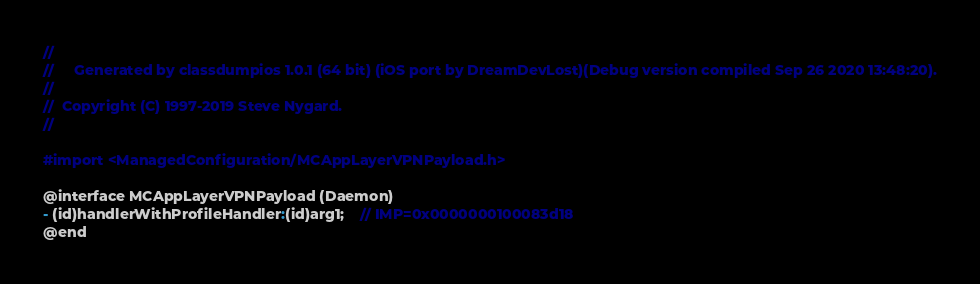Convert code to text. <code><loc_0><loc_0><loc_500><loc_500><_C_>//
//     Generated by classdumpios 1.0.1 (64 bit) (iOS port by DreamDevLost)(Debug version compiled Sep 26 2020 13:48:20).
//
//  Copyright (C) 1997-2019 Steve Nygard.
//

#import <ManagedConfiguration/MCAppLayerVPNPayload.h>

@interface MCAppLayerVPNPayload (Daemon)
- (id)handlerWithProfileHandler:(id)arg1;	// IMP=0x0000000100083d18
@end

</code> 